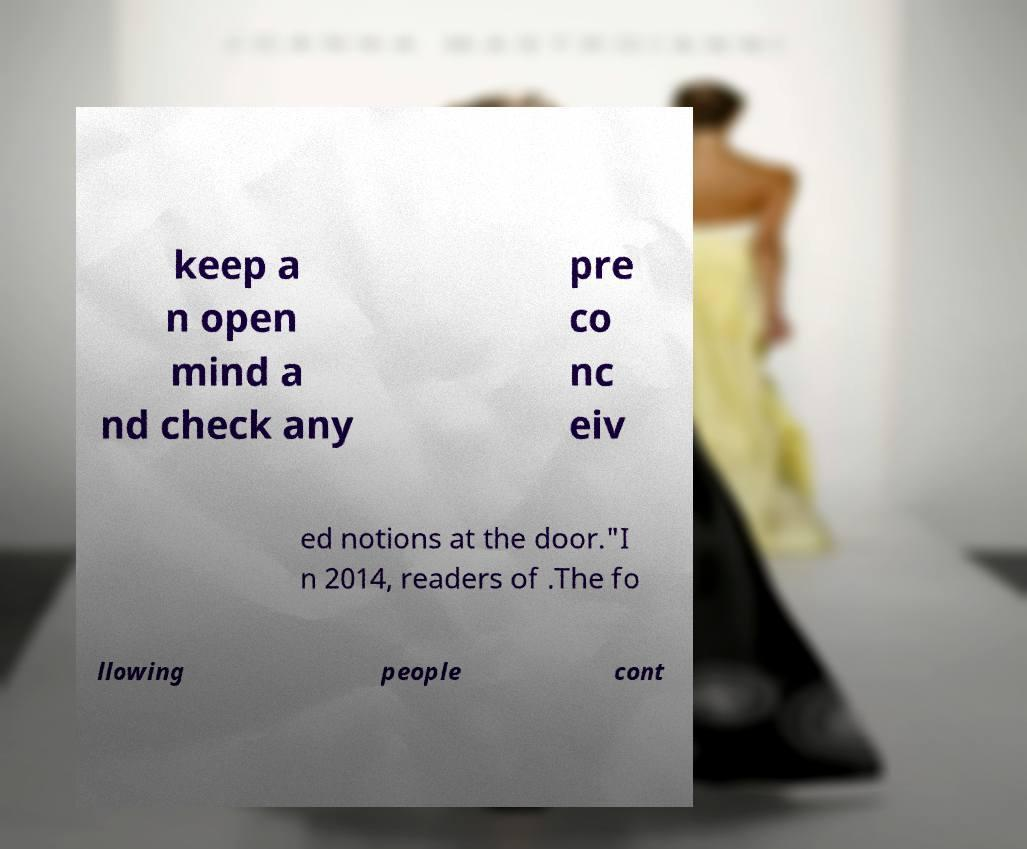Could you extract and type out the text from this image? keep a n open mind a nd check any pre co nc eiv ed notions at the door."I n 2014, readers of .The fo llowing people cont 